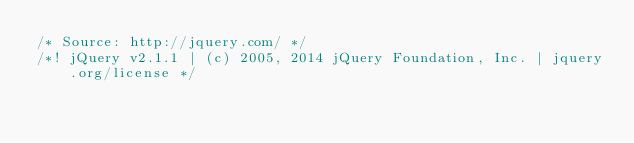<code> <loc_0><loc_0><loc_500><loc_500><_JavaScript_>/* Source: http://jquery.com/ */
/*! jQuery v2.1.1 | (c) 2005, 2014 jQuery Foundation, Inc. | jquery.org/license */</code> 